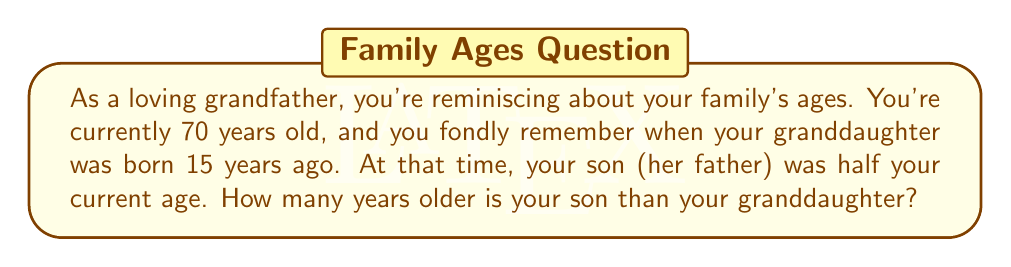Could you help me with this problem? Let's approach this step-by-step:

1. First, let's identify the known information:
   - You (grandfather) are currently 70 years old
   - Your granddaughter is 15 years old
   - When your granddaughter was born, your son was half your current age

2. Calculate your son's age when your granddaughter was born:
   $$\text{Son's age at granddaughter's birth} = \frac{1}{2} \times 70 = 35$$

3. Now, we need to find the age difference between your son and granddaughter:
   $$\text{Age difference} = \text{Son's age at granddaughter's birth} - \text{Granddaughter's age at birth}$$
   $$\text{Age difference} = 35 - 0 = 35$$

4. This age difference remains constant over time, so it's still valid today.

Therefore, your son is 35 years older than your granddaughter.
Answer: $35$ years 